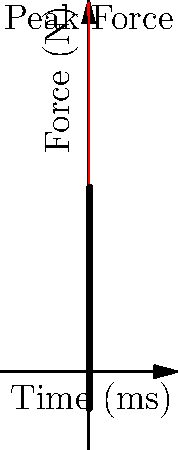In a championship game at Minute Maid Park, an Astros player hits a home run. The graph shows the force exerted on the baseball bat during the collision with the ball. If the collision lasts for 20 milliseconds, what is the average force exerted on the bat during this time? Let's approach this step-by-step:

1) The graph shows the force (in Newtons) over time (in milliseconds).

2) To find the average force, we need to calculate the area under the curve and divide it by the total time.

3) The area under the curve represents the impulse, which is equal to the change in momentum.

4) We can approximate the area under the curve by treating it as a triangle:
   Area ≈ $\frac{1}{2} \times$ base $\times$ height
   
5) The base of our triangle is 20 ms (the duration of the collision).

6) The height is the peak force, which appears to be about 10,000 N.

7) So, the approximate area (impulse) is:
   Impulse ≈ $\frac{1}{2} \times 20 \text{ ms} \times 10,000 \text{ N} = 100,000 \text{ N⋅ms}$

8) To get the average force, we divide this by the total time:
   $F_{avg} = \frac{\text{Impulse}}{\text{Time}} = \frac{100,000 \text{ N⋅ms}}{20 \text{ ms}} = 5,000 \text{ N}$

Therefore, the average force exerted on the bat during this home run hit is approximately 5,000 N.
Answer: 5,000 N 